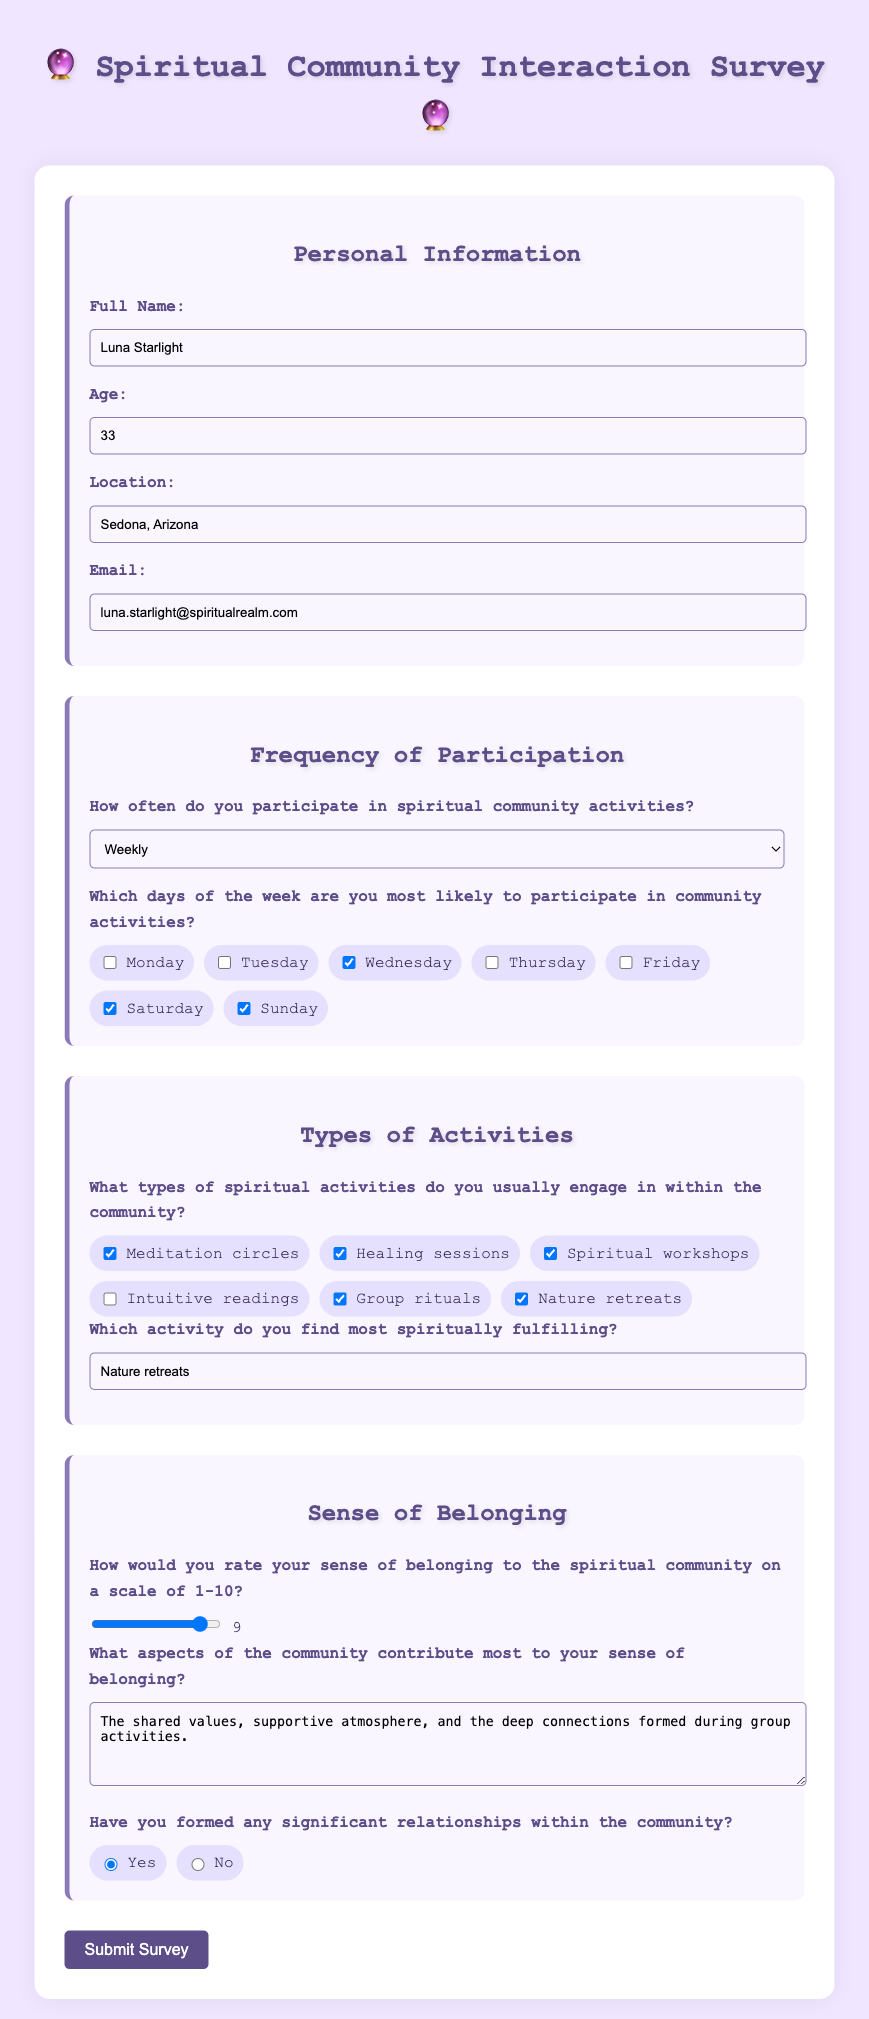What is the name of the participant? The name of the participant is provided in the personal information section of the document.
Answer: Luna Starlight How old is the participant? The age of the participant is specified in the personal information section.
Answer: 33 What is the participant's email address? The email address is included in the personal information section.
Answer: luna.starlight@spiritualrealm.com How often does the participant participate in spiritual community activities? This is indicated in the frequency of participation section of the document.
Answer: Weekly Which day is the participant most likely to participate? The participant's most likely participation day can be inferred from the checkboxes in the frequency section.
Answer: Wednesday, Saturday, Sunday What types of activities does the participant engage in? The participant's chosen activities are listed in the types of activities section of the document.
Answer: Meditation circles, Healing sessions, Spiritual workshops, Group rituals, Nature retreats Which activity does the participant find most spiritually fulfilling? This is mentioned in the types of activities section where they specify a fulfilling activity.
Answer: Nature retreats On a scale of 1-10, how would the participant rate their sense of belonging? The rating is indicated by the number selected in the sense of belonging section.
Answer: 9 What aspects contribute to the participant's sense of belonging? The participant provided a response in the sense of belonging section regarding what contributes to their belonging.
Answer: The shared values, supportive atmosphere, and the deep connections formed during group activities Has the participant formed significant relationships within the community? This is answered in a yes/no format in the sense of belonging section.
Answer: Yes 